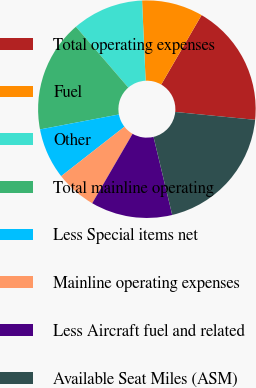<chart> <loc_0><loc_0><loc_500><loc_500><pie_chart><fcel>Total operating expenses<fcel>Fuel<fcel>Other<fcel>Total mainline operating<fcel>Less Special items net<fcel>Mainline operating expenses<fcel>Less Aircraft fuel and related<fcel>Available Seat Miles (ASM)<nl><fcel>18.18%<fcel>9.09%<fcel>10.61%<fcel>16.67%<fcel>7.58%<fcel>6.06%<fcel>12.12%<fcel>19.7%<nl></chart> 